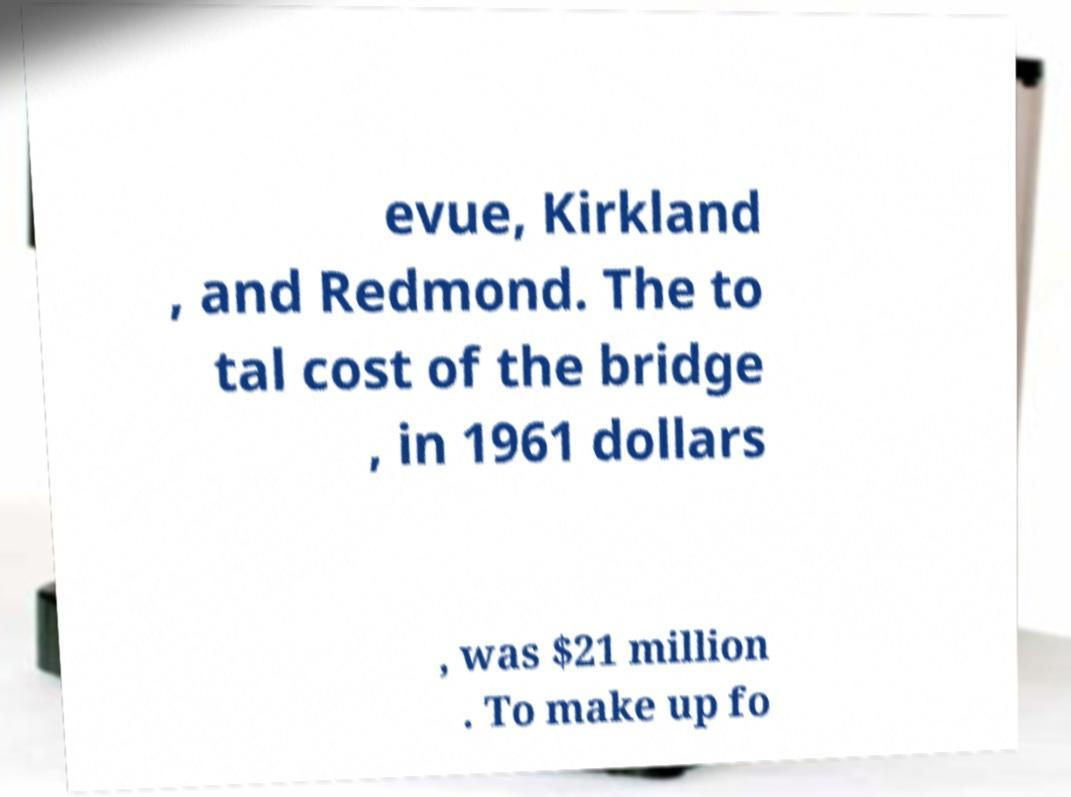Please read and relay the text visible in this image. What does it say? evue, Kirkland , and Redmond. The to tal cost of the bridge , in 1961 dollars , was $21 million . To make up fo 